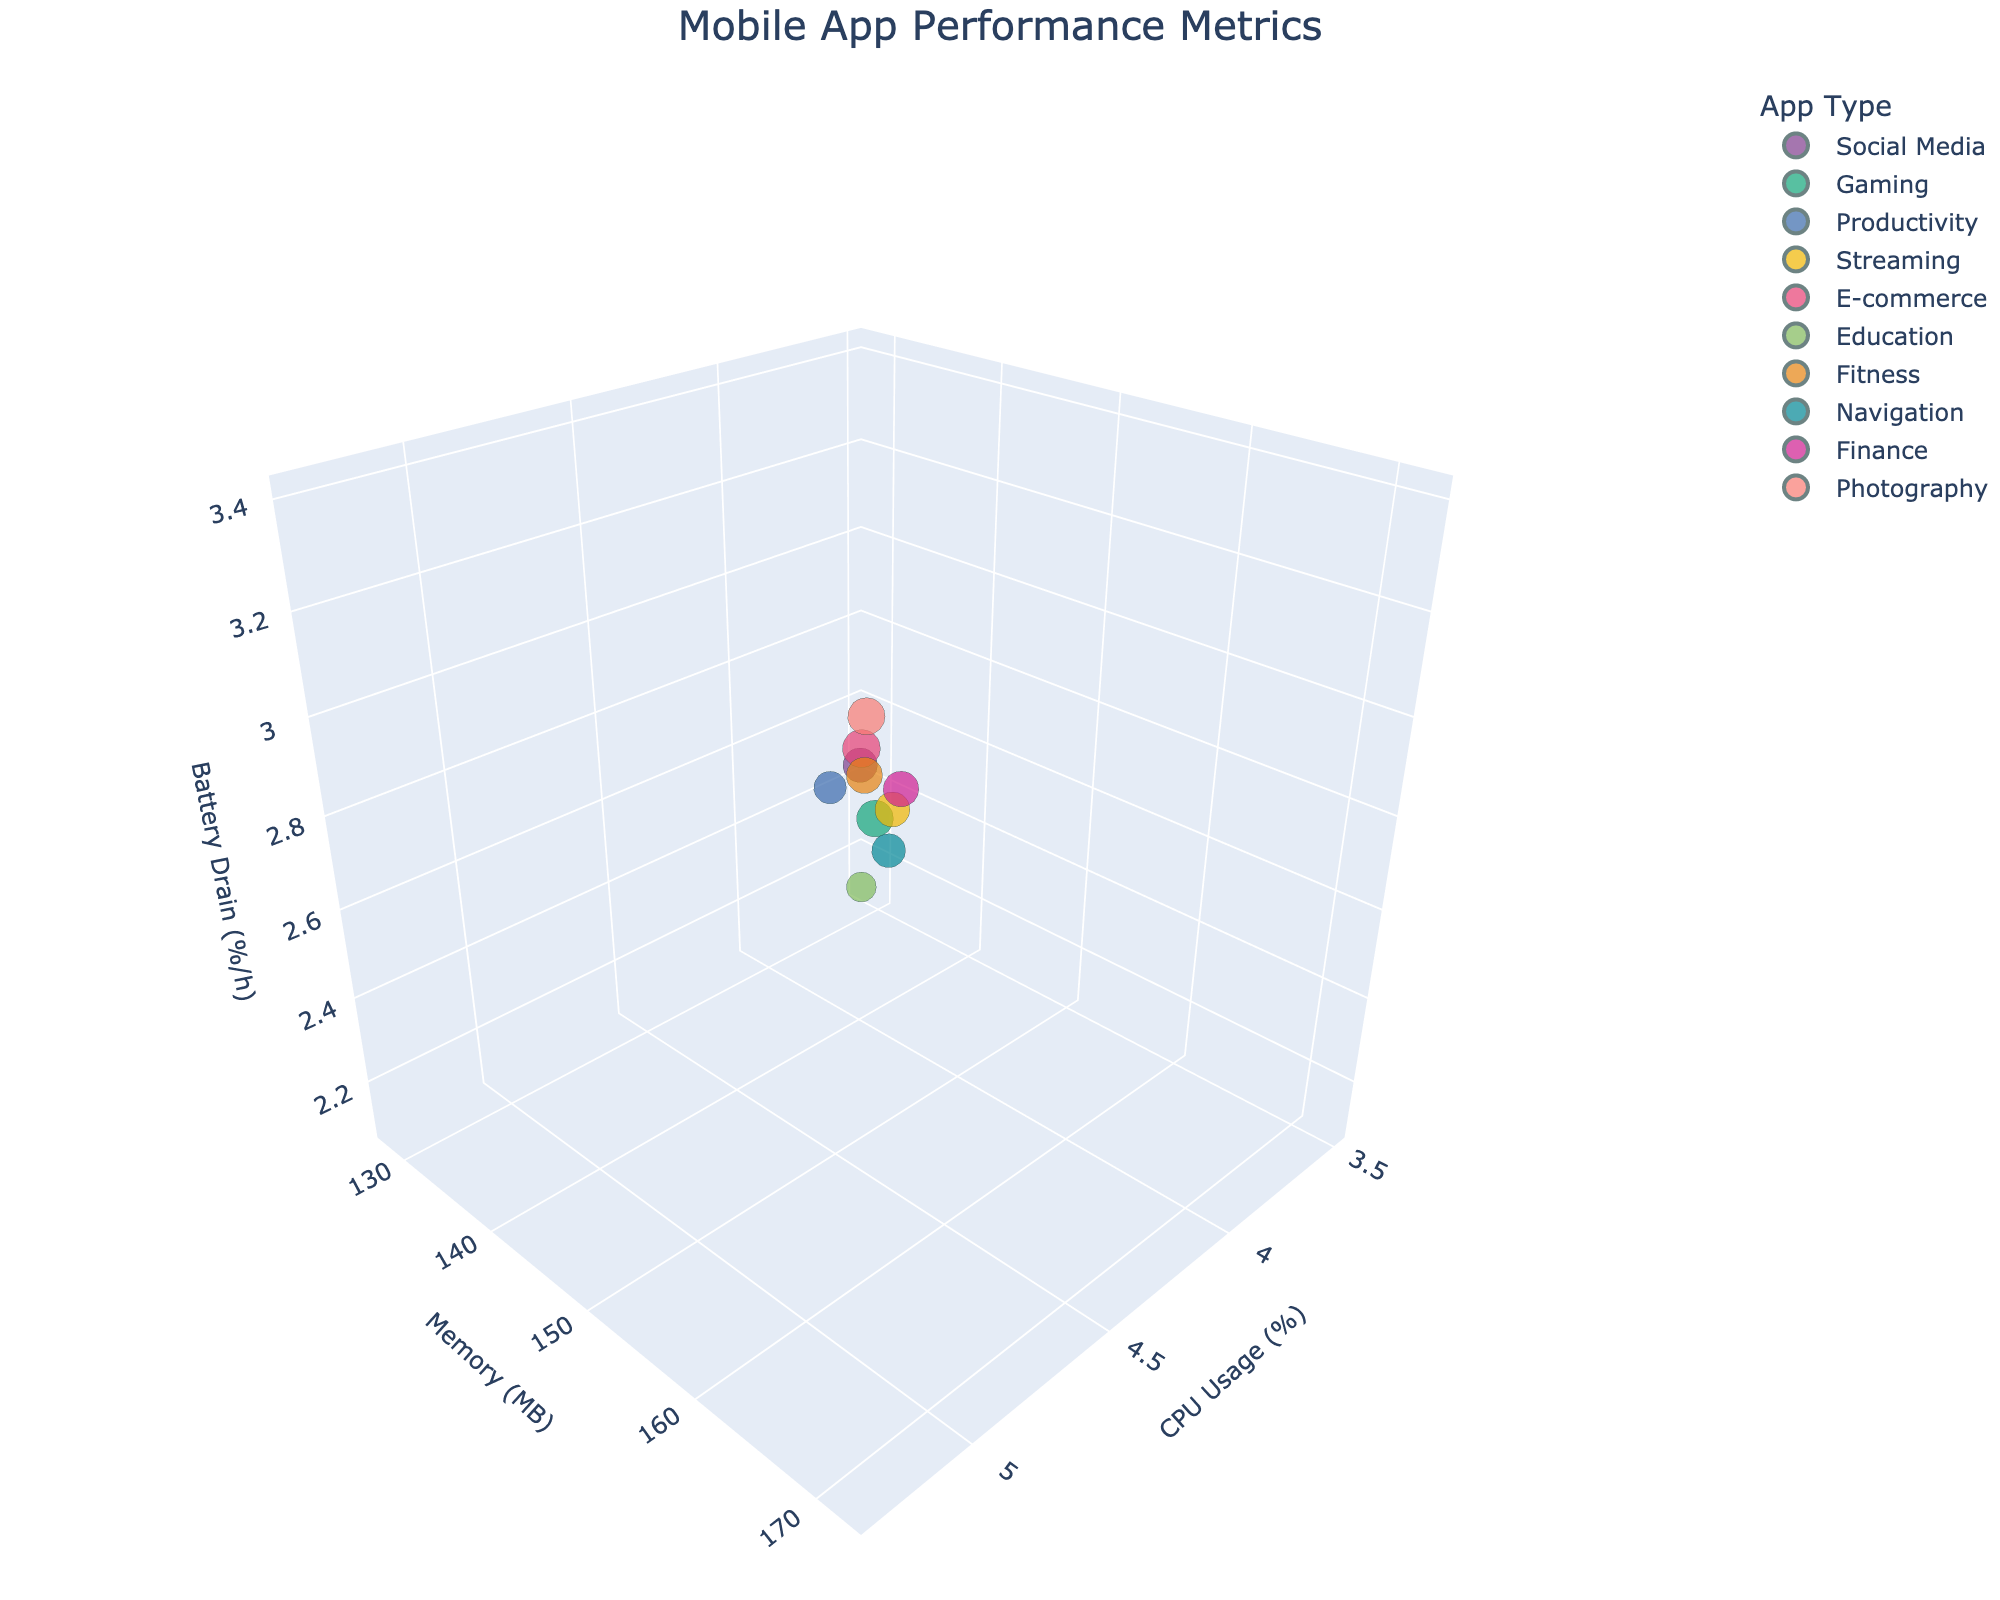What's the title of the chart? The title is displayed at the top of the figure in a larger font, reading "Mobile App Performance Metrics".
Answer: Mobile App Performance Metrics What are the labels of the x, y, and z axes? The x-axis is labeled "CPU Usage (%)", the y-axis is labeled "Memory (MB)", and the z-axis is labeled "Battery Drain (%/h)". These labels are usually found near the axes themselves.
Answer: CPU Usage (%), Memory (MB), Battery Drain (%/h) How many different app types are represented in the chart? Each unique color in the chart represents a different app type. By counting the different colors and referring to the legend, we can see the number of app types.
Answer: 10 Which device has the highest battery drain rate? By locating the highest point along the z-axis labeled "Battery Drain (%/h)", we can determine the device. Hovering over the points can provide the device names.
Answer: Xiaomi Mi 11 Which app type is associated with the device that has the lowest memory consumption? Find the lowest point on the y-axis labeled "Memory (MB)" and identify the corresponding bubble's color to match the app type from the legend.
Answer: Education What's the sum of CPU usage percentages for devices used in Gaming and Social Media apps? Identify the colors of Gaming and Social Media apps in the legend, sum the CPU usage percentages of those bubbles. Gaming: Samsung Galaxy S21 (5.1), Social Media: iPhone 12 (4.2). 5.1 + 4.2 = 9.3
Answer: 9.3 Which app type shows the highest variation in CPU usage among devices? Examine the spread of data points in the x-axis for each app type and identify the one with the widest spread or largest distance between data points.
Answer: E-commerce Are there any devices with exactly equal memory consumption but different battery drain rates? Identify points with the same y-axis value and compare their z-axis values. One example is Samsung Galaxy S21 (168 MB, 3.2) and Sony Xperia 1 III (165 MB, 3.3 MB). The two devices with exactly equal memory consumption (155 MB) are OnePlus 9 and Motorola Edge.
Answer: No What is the average battery drain rate for all devices? Sum all the z-axis values and divide by the number of devices. Values: 2.8, 3.2, 2.5, 2.9, 3.4, 2.1, 3.1, 2.7, 3.0, 3.3. Average = (2.8+3.2+2.5+2.9+3.4+2.1+3.1+2.7+3.0+3.3)/10 = 2.9
Answer: 2.9 Which device and app type combination shows the lowest CPU usage? Find the lowest point on the x-axis and identify the corresponding device using the hover tooltip.
Answer: iPad Air, Education 